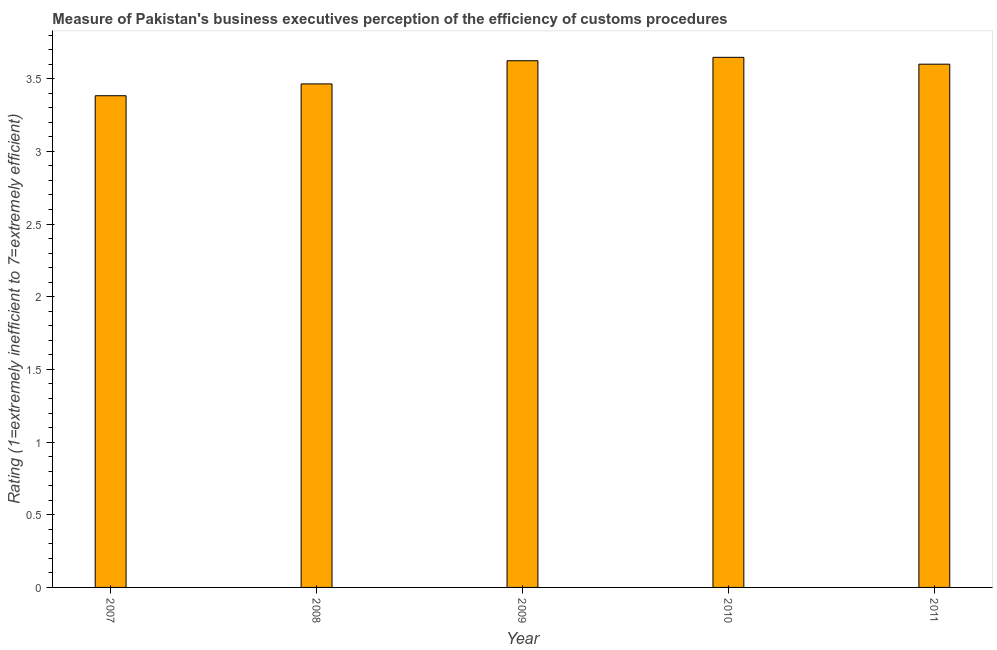Does the graph contain grids?
Offer a very short reply. No. What is the title of the graph?
Your answer should be very brief. Measure of Pakistan's business executives perception of the efficiency of customs procedures. What is the label or title of the Y-axis?
Make the answer very short. Rating (1=extremely inefficient to 7=extremely efficient). What is the rating measuring burden of customs procedure in 2007?
Keep it short and to the point. 3.38. Across all years, what is the maximum rating measuring burden of customs procedure?
Give a very brief answer. 3.65. Across all years, what is the minimum rating measuring burden of customs procedure?
Keep it short and to the point. 3.38. In which year was the rating measuring burden of customs procedure minimum?
Provide a short and direct response. 2007. What is the sum of the rating measuring burden of customs procedure?
Provide a short and direct response. 17.72. What is the difference between the rating measuring burden of customs procedure in 2007 and 2008?
Offer a terse response. -0.08. What is the average rating measuring burden of customs procedure per year?
Make the answer very short. 3.54. Do a majority of the years between 2008 and 2009 (inclusive) have rating measuring burden of customs procedure greater than 2.8 ?
Give a very brief answer. Yes. What is the ratio of the rating measuring burden of customs procedure in 2008 to that in 2009?
Offer a very short reply. 0.96. What is the difference between the highest and the second highest rating measuring burden of customs procedure?
Ensure brevity in your answer.  0.02. What is the difference between the highest and the lowest rating measuring burden of customs procedure?
Offer a terse response. 0.26. How many bars are there?
Provide a succinct answer. 5. Are all the bars in the graph horizontal?
Keep it short and to the point. No. How many years are there in the graph?
Give a very brief answer. 5. What is the difference between two consecutive major ticks on the Y-axis?
Give a very brief answer. 0.5. What is the Rating (1=extremely inefficient to 7=extremely efficient) in 2007?
Give a very brief answer. 3.38. What is the Rating (1=extremely inefficient to 7=extremely efficient) of 2008?
Provide a succinct answer. 3.46. What is the Rating (1=extremely inefficient to 7=extremely efficient) in 2009?
Your answer should be very brief. 3.62. What is the Rating (1=extremely inefficient to 7=extremely efficient) in 2010?
Offer a terse response. 3.65. What is the difference between the Rating (1=extremely inefficient to 7=extremely efficient) in 2007 and 2008?
Offer a very short reply. -0.08. What is the difference between the Rating (1=extremely inefficient to 7=extremely efficient) in 2007 and 2009?
Your response must be concise. -0.24. What is the difference between the Rating (1=extremely inefficient to 7=extremely efficient) in 2007 and 2010?
Ensure brevity in your answer.  -0.26. What is the difference between the Rating (1=extremely inefficient to 7=extremely efficient) in 2007 and 2011?
Offer a terse response. -0.22. What is the difference between the Rating (1=extremely inefficient to 7=extremely efficient) in 2008 and 2009?
Your response must be concise. -0.16. What is the difference between the Rating (1=extremely inefficient to 7=extremely efficient) in 2008 and 2010?
Provide a succinct answer. -0.18. What is the difference between the Rating (1=extremely inefficient to 7=extremely efficient) in 2008 and 2011?
Provide a short and direct response. -0.14. What is the difference between the Rating (1=extremely inefficient to 7=extremely efficient) in 2009 and 2010?
Your answer should be very brief. -0.02. What is the difference between the Rating (1=extremely inefficient to 7=extremely efficient) in 2009 and 2011?
Your answer should be compact. 0.02. What is the difference between the Rating (1=extremely inefficient to 7=extremely efficient) in 2010 and 2011?
Keep it short and to the point. 0.05. What is the ratio of the Rating (1=extremely inefficient to 7=extremely efficient) in 2007 to that in 2008?
Your answer should be compact. 0.98. What is the ratio of the Rating (1=extremely inefficient to 7=extremely efficient) in 2007 to that in 2009?
Offer a very short reply. 0.93. What is the ratio of the Rating (1=extremely inefficient to 7=extremely efficient) in 2007 to that in 2010?
Make the answer very short. 0.93. What is the ratio of the Rating (1=extremely inefficient to 7=extremely efficient) in 2007 to that in 2011?
Provide a short and direct response. 0.94. What is the ratio of the Rating (1=extremely inefficient to 7=extremely efficient) in 2008 to that in 2009?
Offer a very short reply. 0.96. What is the ratio of the Rating (1=extremely inefficient to 7=extremely efficient) in 2010 to that in 2011?
Your answer should be compact. 1.01. 